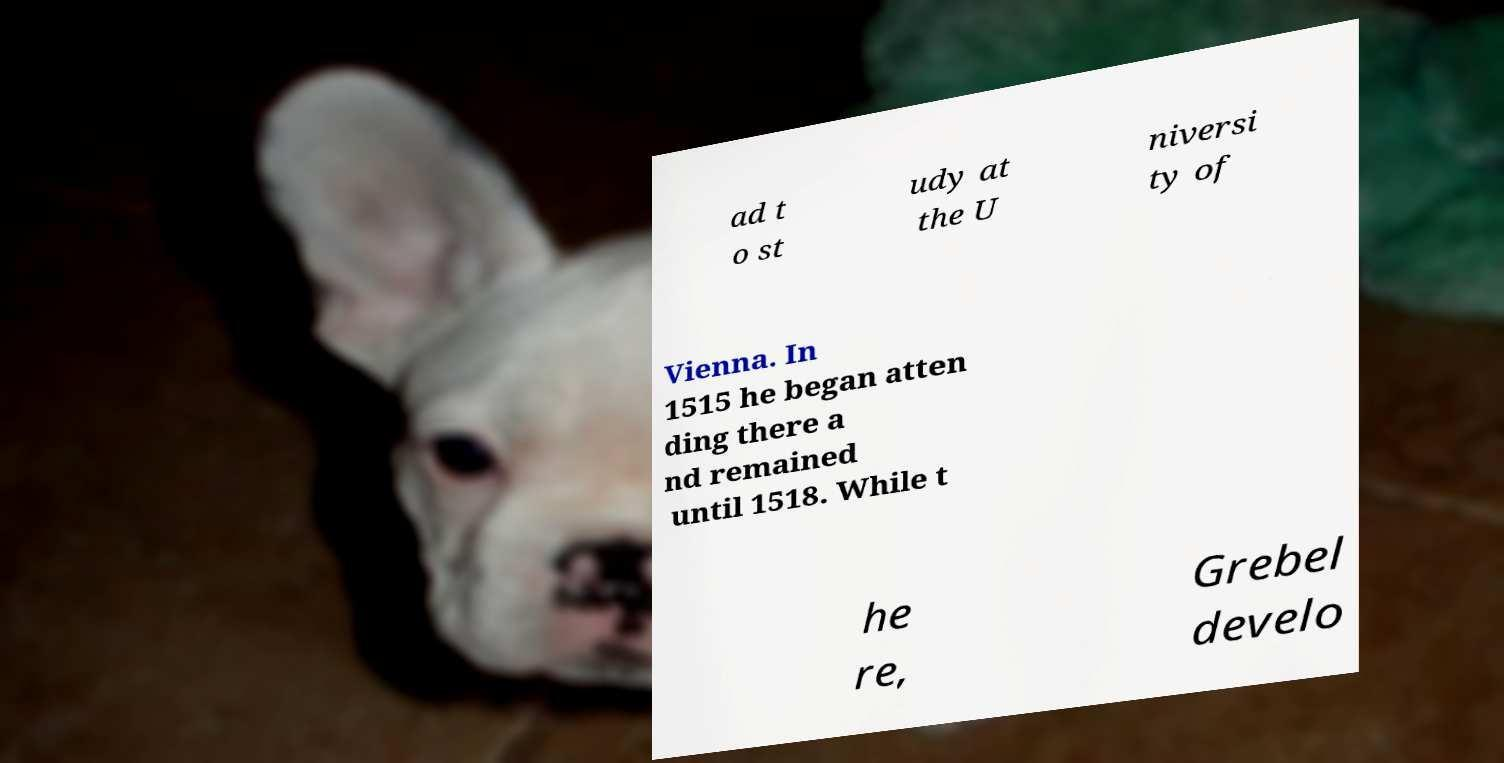Could you extract and type out the text from this image? ad t o st udy at the U niversi ty of Vienna. In 1515 he began atten ding there a nd remained until 1518. While t he re, Grebel develo 